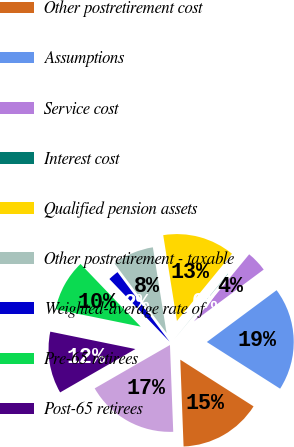Convert chart to OTSL. <chart><loc_0><loc_0><loc_500><loc_500><pie_chart><fcel>Qualified pension cost<fcel>Other postretirement cost<fcel>Assumptions<fcel>Service cost<fcel>Interest cost<fcel>Qualified pension assets<fcel>Other postretirement - taxable<fcel>Weighted-average rate of<fcel>Pre-65 retirees<fcel>Post-65 retirees<nl><fcel>17.28%<fcel>15.37%<fcel>19.2%<fcel>3.87%<fcel>0.04%<fcel>13.45%<fcel>7.7%<fcel>1.95%<fcel>9.62%<fcel>11.53%<nl></chart> 